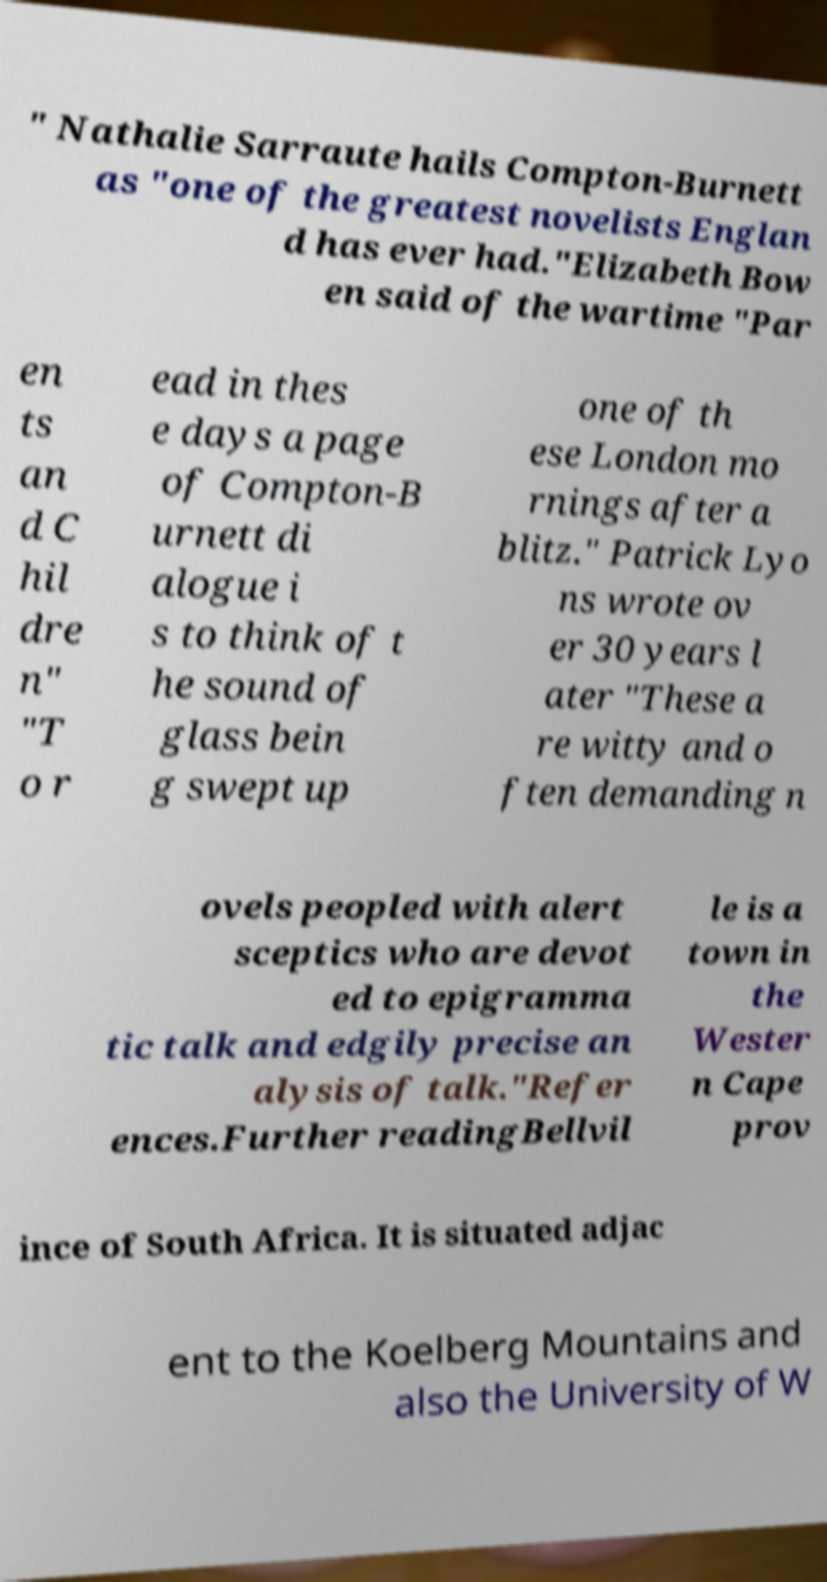Please read and relay the text visible in this image. What does it say? " Nathalie Sarraute hails Compton-Burnett as "one of the greatest novelists Englan d has ever had."Elizabeth Bow en said of the wartime "Par en ts an d C hil dre n" "T o r ead in thes e days a page of Compton-B urnett di alogue i s to think of t he sound of glass bein g swept up one of th ese London mo rnings after a blitz." Patrick Lyo ns wrote ov er 30 years l ater "These a re witty and o ften demanding n ovels peopled with alert sceptics who are devot ed to epigramma tic talk and edgily precise an alysis of talk."Refer ences.Further readingBellvil le is a town in the Wester n Cape prov ince of South Africa. It is situated adjac ent to the Koelberg Mountains and also the University of W 